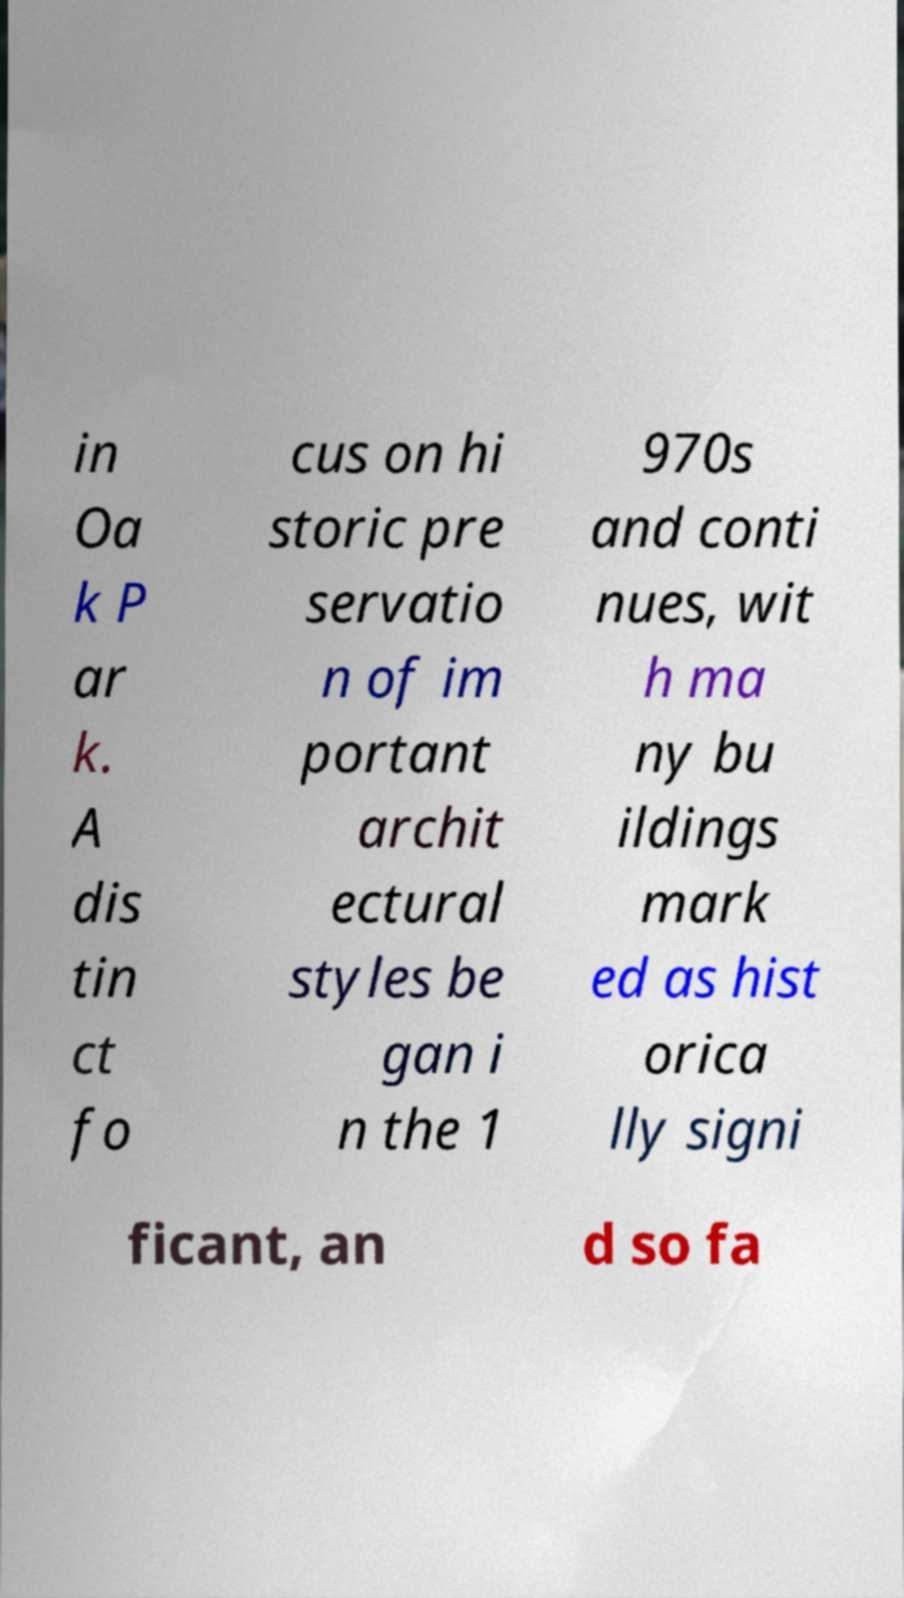Please identify and transcribe the text found in this image. in Oa k P ar k. A dis tin ct fo cus on hi storic pre servatio n of im portant archit ectural styles be gan i n the 1 970s and conti nues, wit h ma ny bu ildings mark ed as hist orica lly signi ficant, an d so fa 